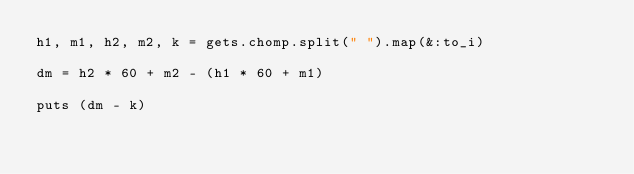<code> <loc_0><loc_0><loc_500><loc_500><_Ruby_>h1, m1, h2, m2, k = gets.chomp.split(" ").map(&:to_i)

dm = h2 * 60 + m2 - (h1 * 60 + m1)

puts (dm - k)
</code> 